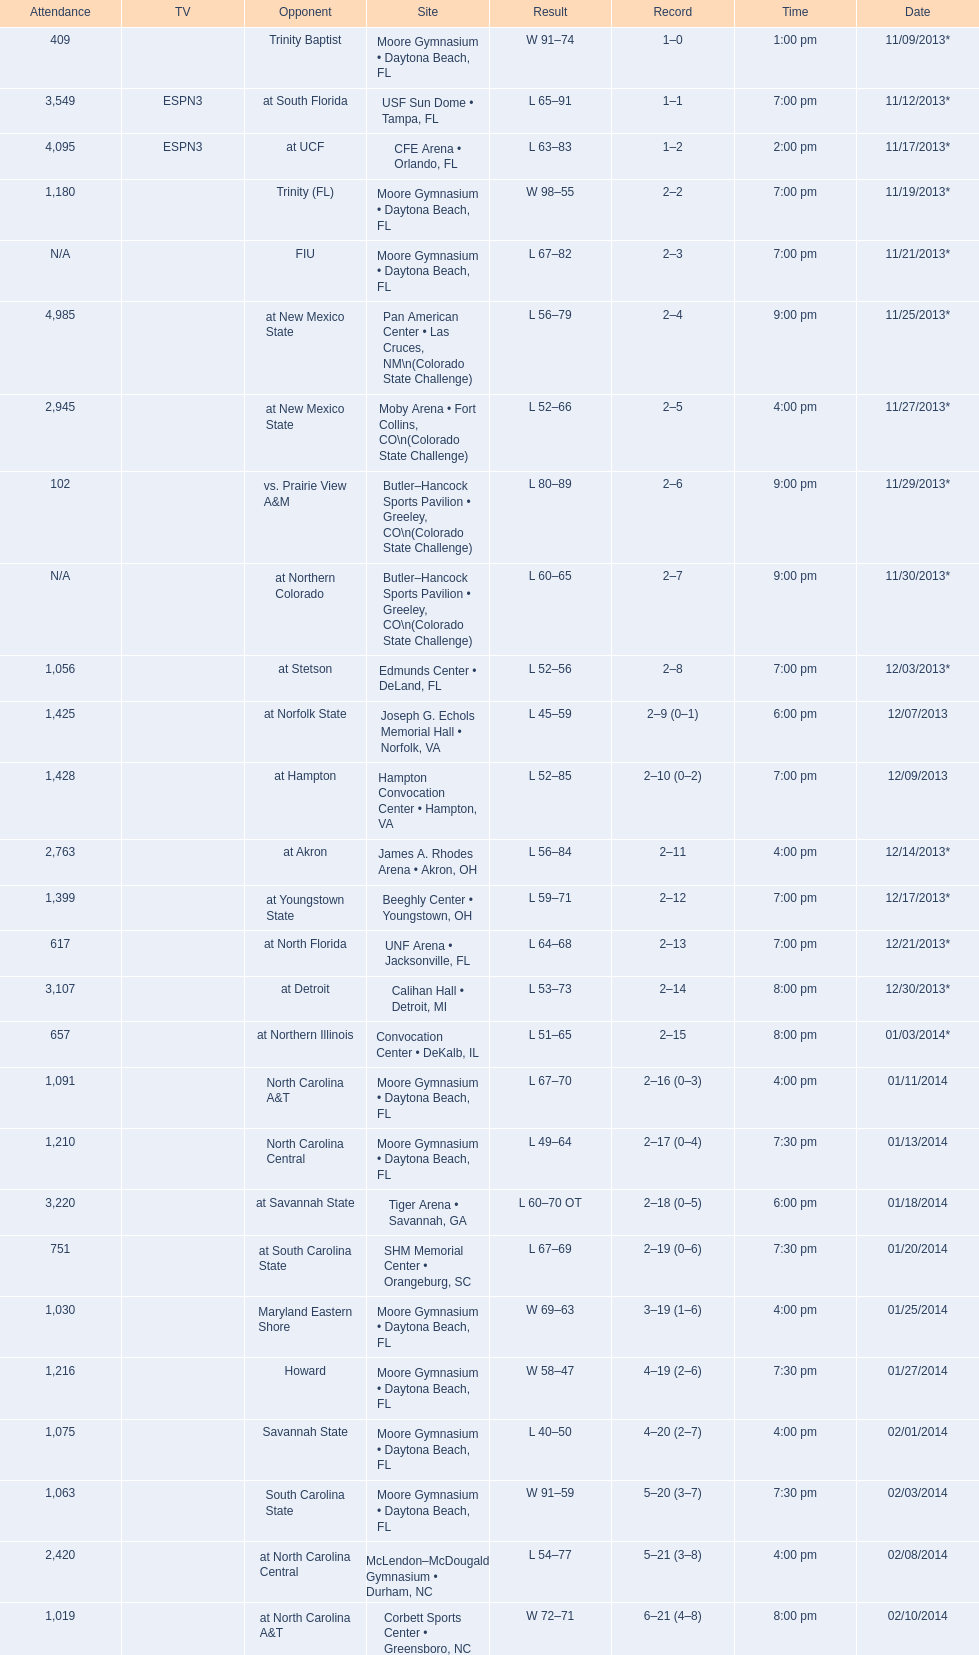How much larger was the attendance on 11/25/2013 than 12/21/2013? 4368. 